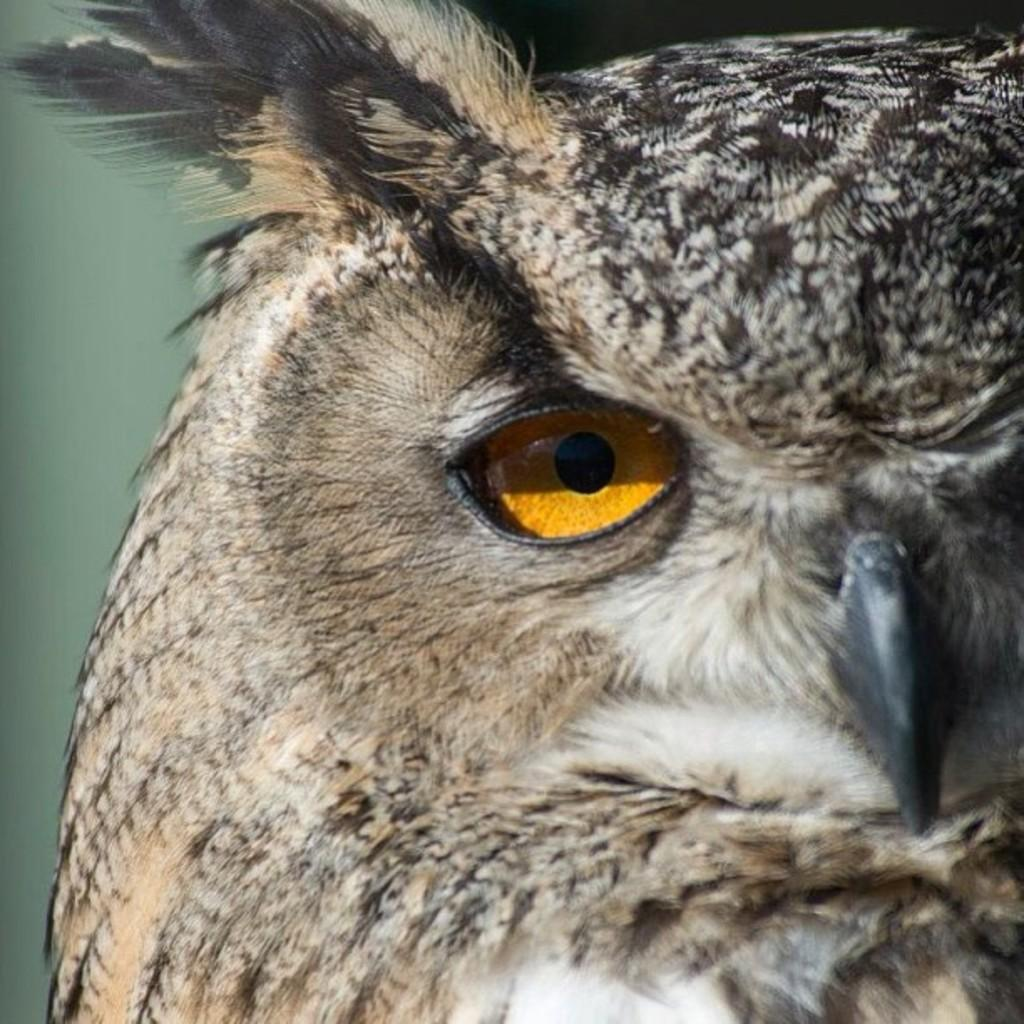What type of animal is in the image? There is an owl in the image. Can you describe the owl's appearance? Only one eye of the owl is visible in the image. What type of glass is the owl drinking from in the image? There is no glass present in the image; it is an owl, not a drinking glass. 